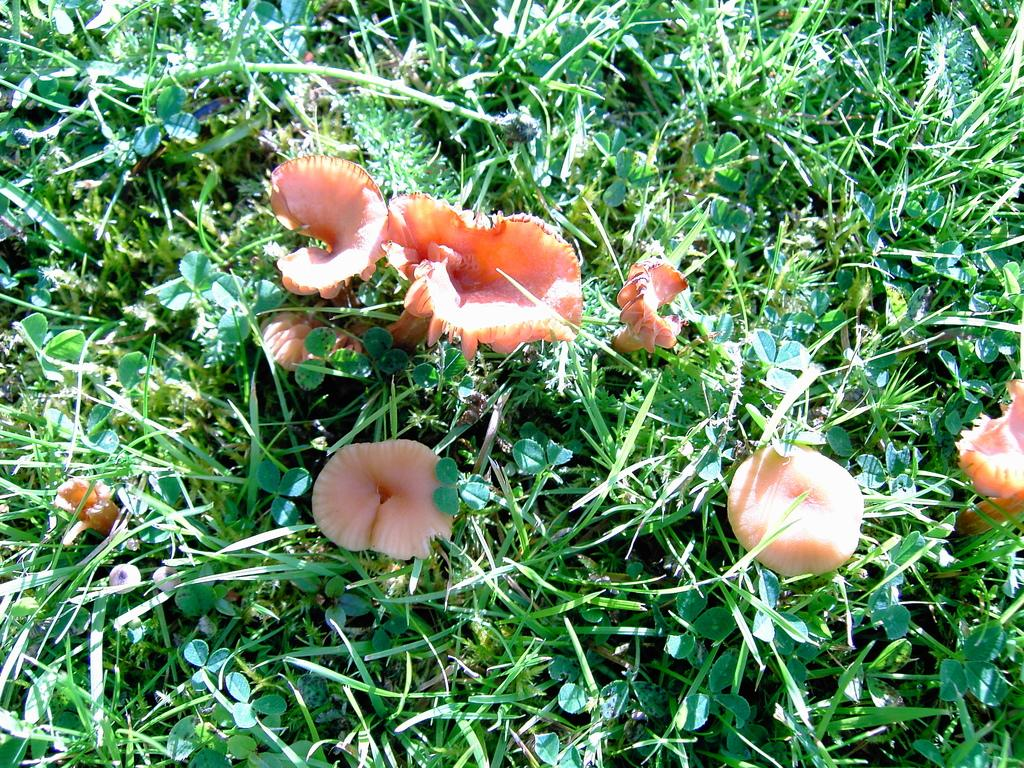What type of plants can be seen in the image? There are flowers and green leaves in the image. Can you describe the color of the flowers? The provided facts do not specify the color of the flowers. What is the color of the leaves in the image? The leaves in the image are green. What type of vest is the flower wearing in the image? There is no vest present in the image, as flowers do not wear clothing. Can you describe the chin of the flower in the image? Flowers do not have chins, as they are not living organisms with facial features. 